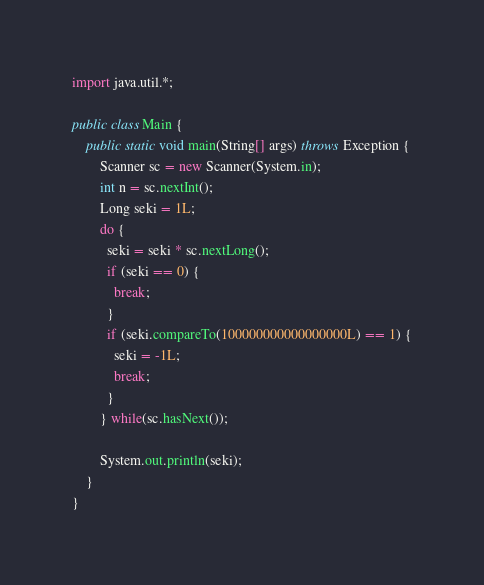<code> <loc_0><loc_0><loc_500><loc_500><_Java_>import java.util.*;

public class Main {
    public static void main(String[] args) throws Exception {
		Scanner sc = new Scanner(System.in);
        int n = sc.nextInt();
      	Long seki = 1L;
      	do {
          seki = seki * sc.nextLong();
          if (seki == 0) {
            break;
          }
          if (seki.compareTo(100000000000000000L) == 1) {
            seki = -1L;
            break;
          }
        } while(sc.hasNext());

        System.out.println(seki);
    }
}</code> 